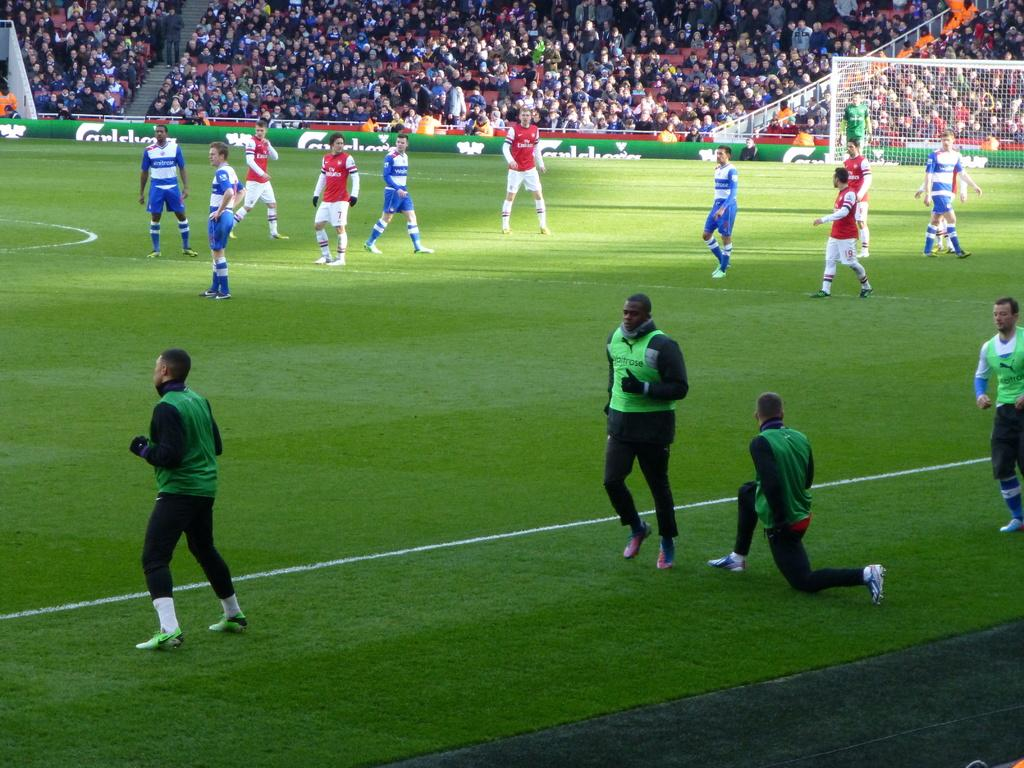What type of venue is shown in the image? There is a football stadium in the image. What activities are the players engaged in? The players are visible in the image, likely playing football. Who else is present in the image besides the players? There is an audience in the image. What type of holiday is being celebrated by the players in the image? There is no indication of a holiday being celebrated in the image; it simply shows a football game in progress. Can you see any lockets being worn by the players in the image? There is no mention of lockets or any jewelry in the image; the focus is on the football game. 